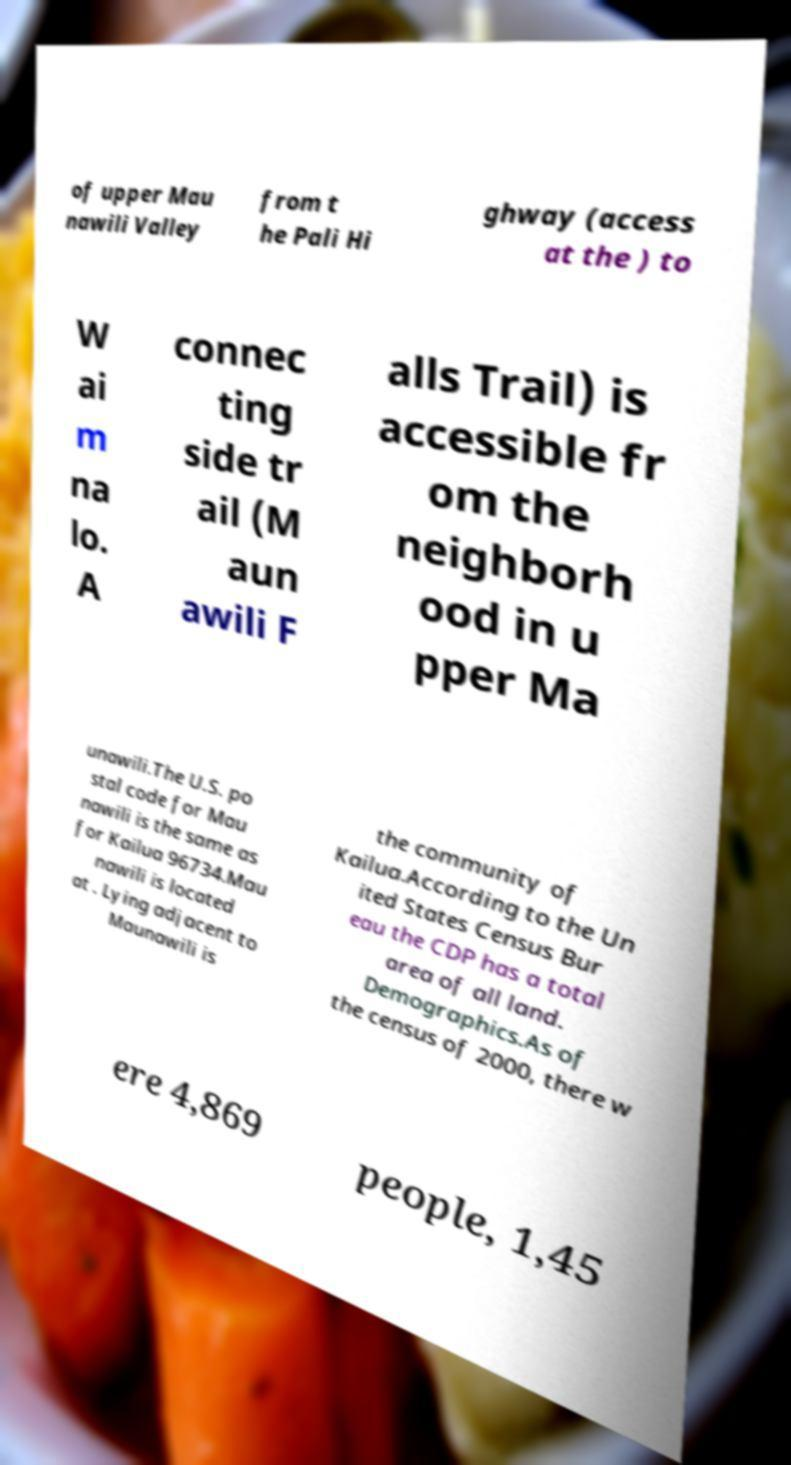Could you extract and type out the text from this image? of upper Mau nawili Valley from t he Pali Hi ghway (access at the ) to W ai m na lo. A connec ting side tr ail (M aun awili F alls Trail) is accessible fr om the neighborh ood in u pper Ma unawili.The U.S. po stal code for Mau nawili is the same as for Kailua 96734.Mau nawili is located at . Lying adjacent to Maunawili is the community of Kailua.According to the Un ited States Census Bur eau the CDP has a total area of all land. Demographics.As of the census of 2000, there w ere 4,869 people, 1,45 